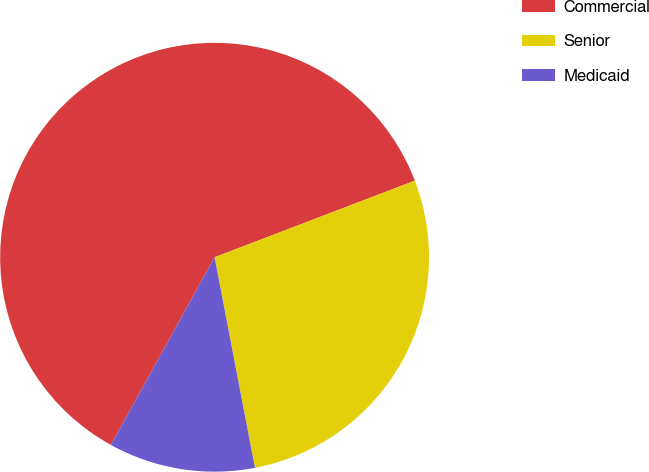Convert chart. <chart><loc_0><loc_0><loc_500><loc_500><pie_chart><fcel>Commercial<fcel>Senior<fcel>Medicaid<nl><fcel>61.15%<fcel>27.8%<fcel>11.05%<nl></chart> 